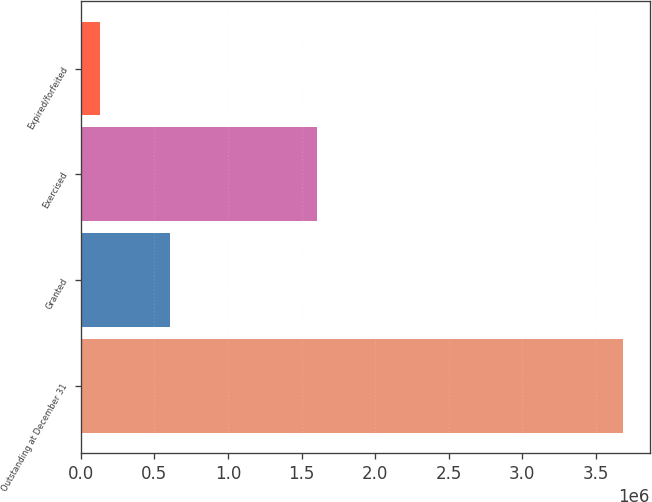Convert chart. <chart><loc_0><loc_0><loc_500><loc_500><bar_chart><fcel>Outstanding at December 31<fcel>Granted<fcel>Exercised<fcel>Expired/forfeited<nl><fcel>3.68296e+06<fcel>603230<fcel>1.606e+06<fcel>129564<nl></chart> 